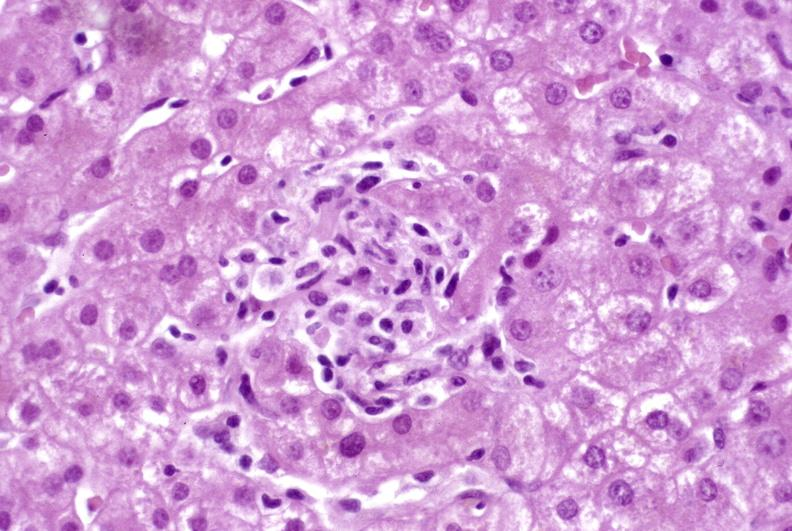what is present?
Answer the question using a single word or phrase. Hepatobiliary 